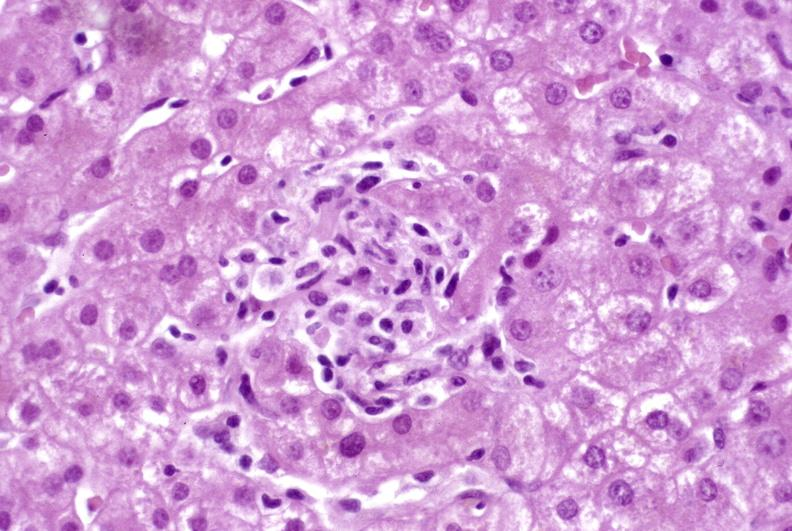what is present?
Answer the question using a single word or phrase. Hepatobiliary 